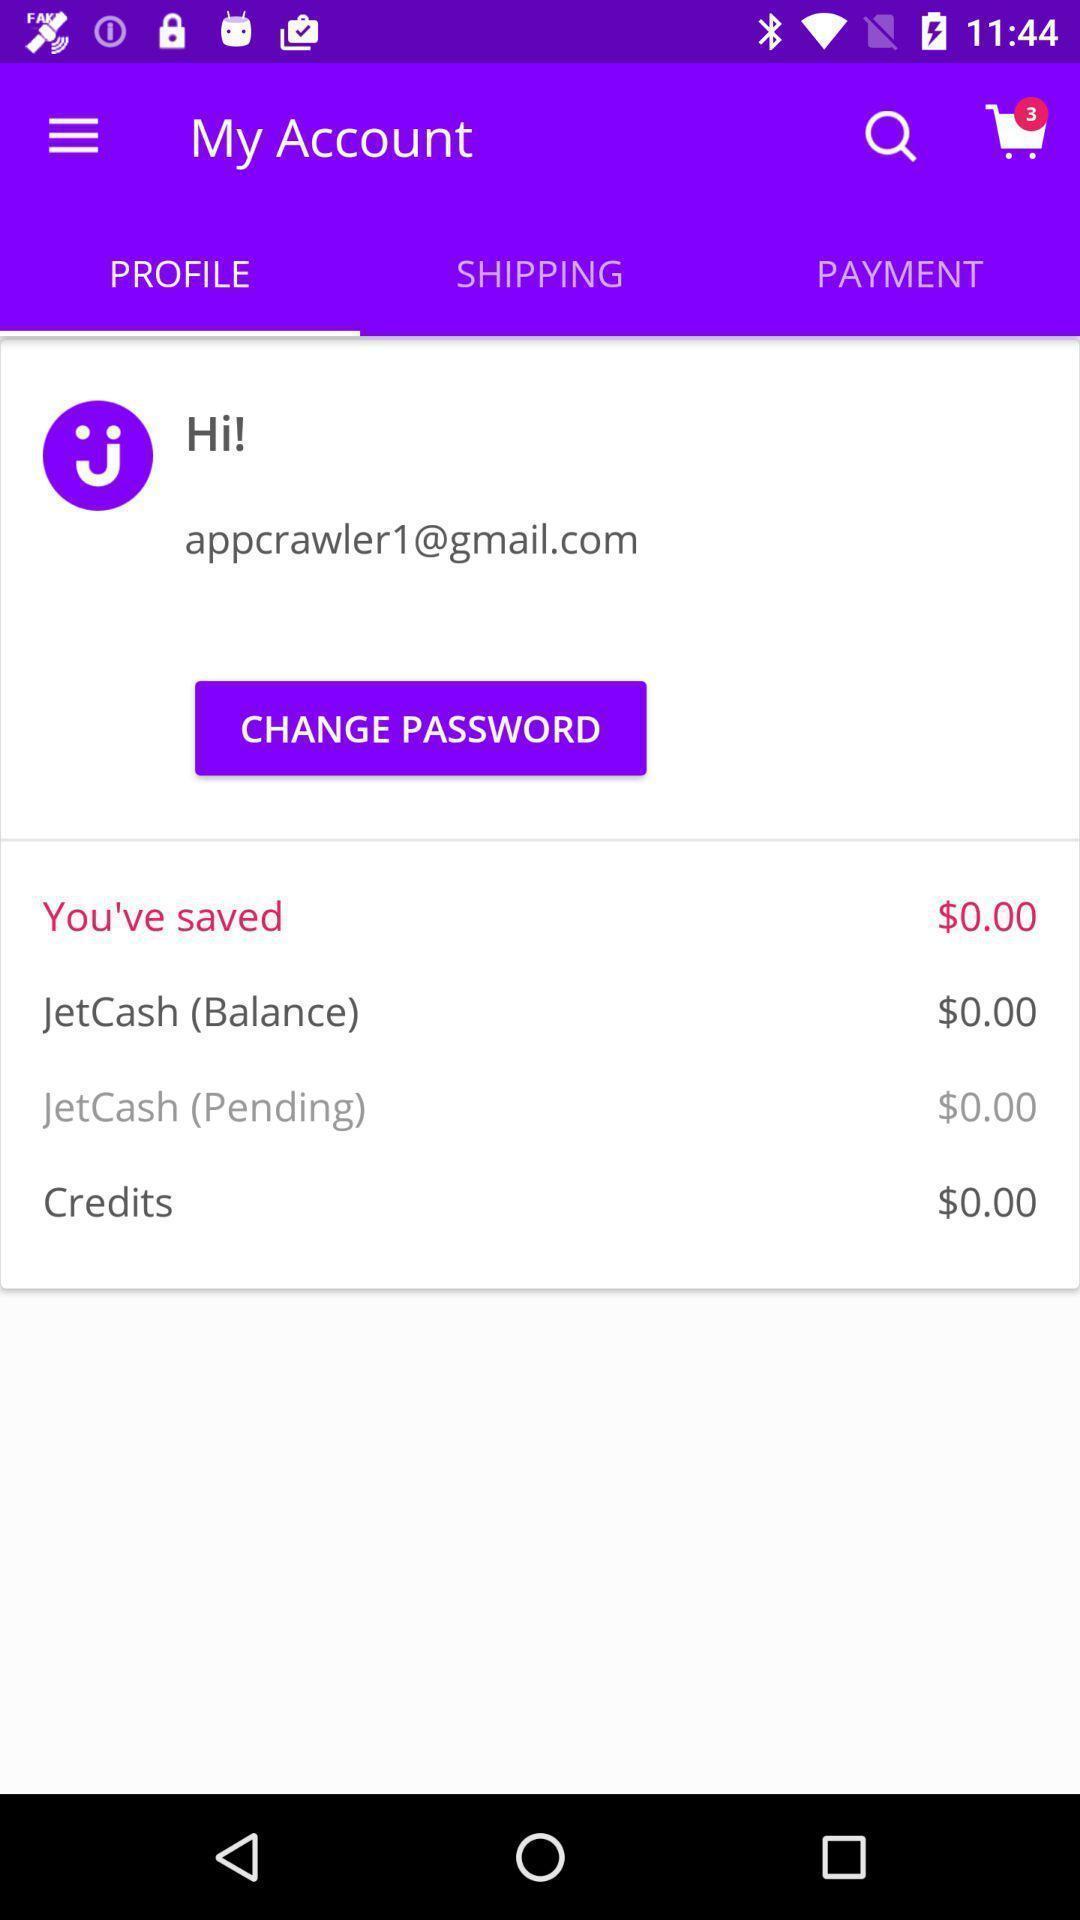What can you discern from this picture? Profile page in a shopping app. 